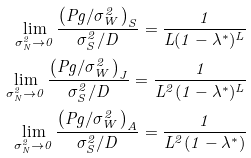Convert formula to latex. <formula><loc_0><loc_0><loc_500><loc_500>\lim _ { \sigma _ { N } ^ { 2 } \rightarrow 0 } \frac { \left ( P g / \sigma _ { W } ^ { 2 } \right ) _ { S } } { \sigma _ { S } ^ { 2 } / D } = \frac { 1 } { L ( 1 - \lambda ^ { * } ) ^ { L } } \\ \lim _ { \sigma _ { N } ^ { 2 } \rightarrow 0 } \frac { \left ( P g / \sigma _ { W } ^ { 2 } \right ) _ { J } } { \sigma _ { S } ^ { 2 } / D } = \frac { 1 } { L ^ { 2 } ( 1 - \lambda ^ { * } ) ^ { L } } \\ \lim _ { \sigma _ { N } ^ { 2 } \rightarrow 0 } \frac { \left ( P g / \sigma _ { W } ^ { 2 } \right ) _ { A } } { \sigma _ { S } ^ { 2 } / D } = \frac { 1 } { L ^ { 2 } ( 1 - \lambda ^ { * } ) }</formula> 